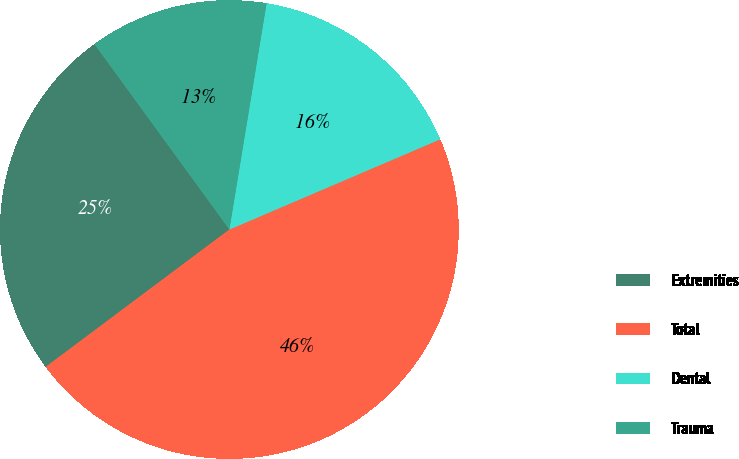Convert chart to OTSL. <chart><loc_0><loc_0><loc_500><loc_500><pie_chart><fcel>Extremities<fcel>Total<fcel>Dental<fcel>Trauma<nl><fcel>25.21%<fcel>46.22%<fcel>15.97%<fcel>12.61%<nl></chart> 